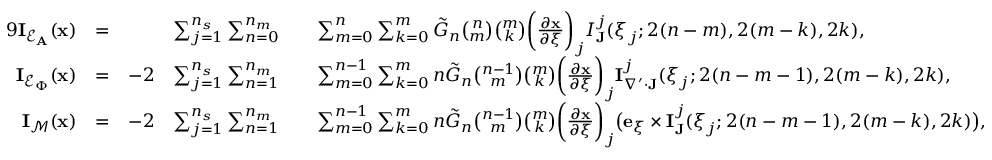Convert formula to latex. <formula><loc_0><loc_0><loc_500><loc_500>\begin{array} { r l r l r l } { { 9 } I _ { \mathcal { E } _ { A } } ( x ) } & { = } & & { \sum _ { j = 1 } ^ { n _ { s } } \sum _ { n = 0 } ^ { n _ { m } } } & & { \sum _ { m = 0 } ^ { n } \sum _ { k = 0 } ^ { m } \tilde { G } _ { n } \binom { n } { m } \binom { m } { k } \left ( \frac { \partial x } { \partial \xi } \right ) _ { j } I _ { J } ^ { j } ( \xi _ { j } ; 2 ( n - m ) , 2 ( m - k ) , 2 k ) , } \\ { I _ { \mathcal { E } _ { \Phi } } ( x ) } & { = } & { - 2 } & { \sum _ { j = 1 } ^ { n _ { s } } \sum _ { n = 1 } ^ { n _ { m } } } & & { \sum _ { m = 0 } ^ { n - 1 } \sum _ { k = 0 } ^ { m } n \tilde { G } _ { n } \binom { n - 1 } { m } \binom { m } { k } \left ( \frac { \partial x } { \partial \xi } \right ) _ { j } I _ { \nabla ^ { \prime } \cdot J } ^ { j } ( \xi _ { j } ; 2 ( n - m - 1 ) , 2 ( m - k ) , 2 k ) , } \\ { I _ { \mathcal { M } } ( x ) } & { = } & { - 2 } & { \sum _ { j = 1 } ^ { n _ { s } } \sum _ { n = 1 } ^ { n _ { m } } } & & { \sum _ { m = 0 } ^ { n - 1 } \sum _ { k = 0 } ^ { m } n \tilde { G } _ { n } \binom { n - 1 } { m } \binom { m } { k } \left ( \frac { \partial x } { \partial \xi } \right ) _ { j } \left ( e _ { \xi } \times I _ { J } ^ { j } ( \xi _ { j } ; 2 ( n - m - 1 ) , 2 ( m - k ) , 2 k ) \right ) , } \end{array}</formula> 